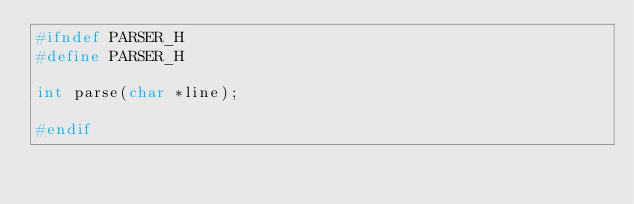Convert code to text. <code><loc_0><loc_0><loc_500><loc_500><_C_>#ifndef PARSER_H
#define PARSER_H       

int parse(char *line);

#endif
</code> 